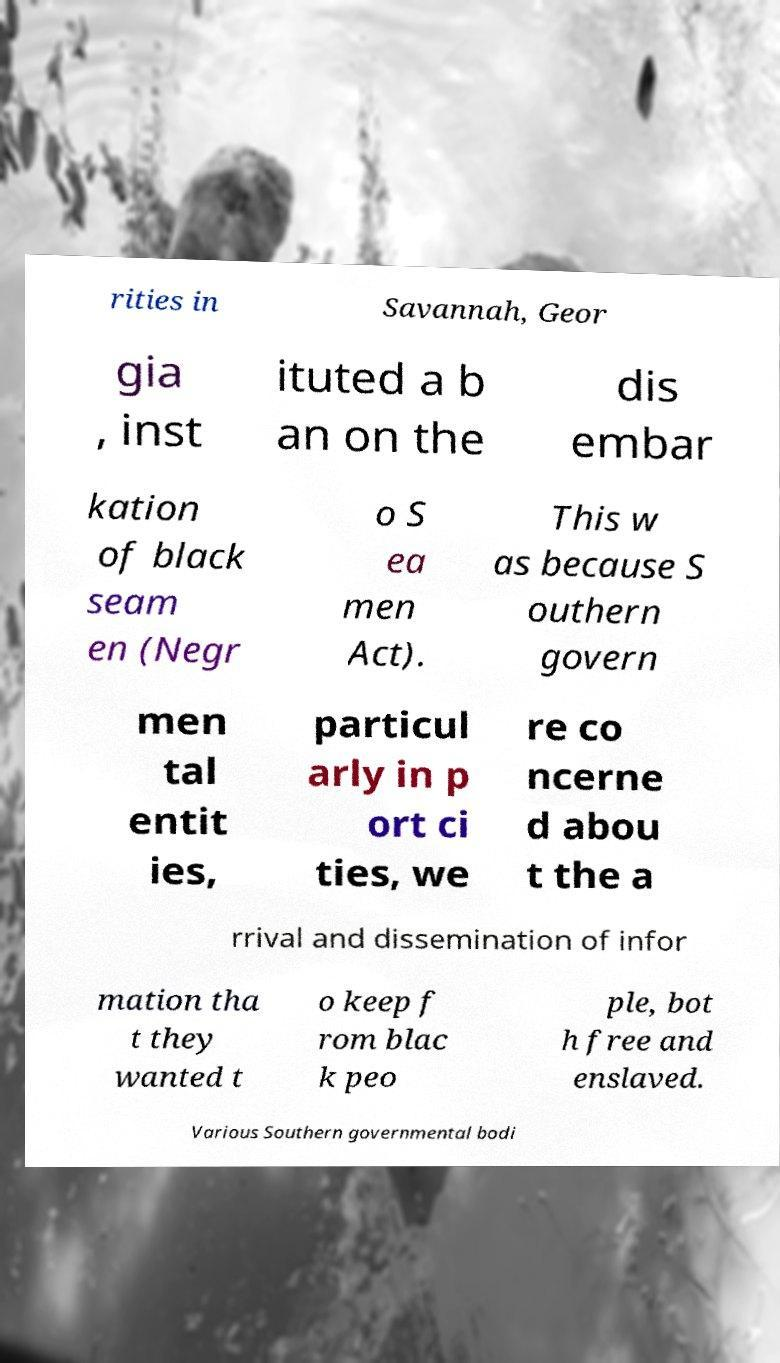Can you accurately transcribe the text from the provided image for me? rities in Savannah, Geor gia , inst ituted a b an on the dis embar kation of black seam en (Negr o S ea men Act). This w as because S outhern govern men tal entit ies, particul arly in p ort ci ties, we re co ncerne d abou t the a rrival and dissemination of infor mation tha t they wanted t o keep f rom blac k peo ple, bot h free and enslaved. Various Southern governmental bodi 